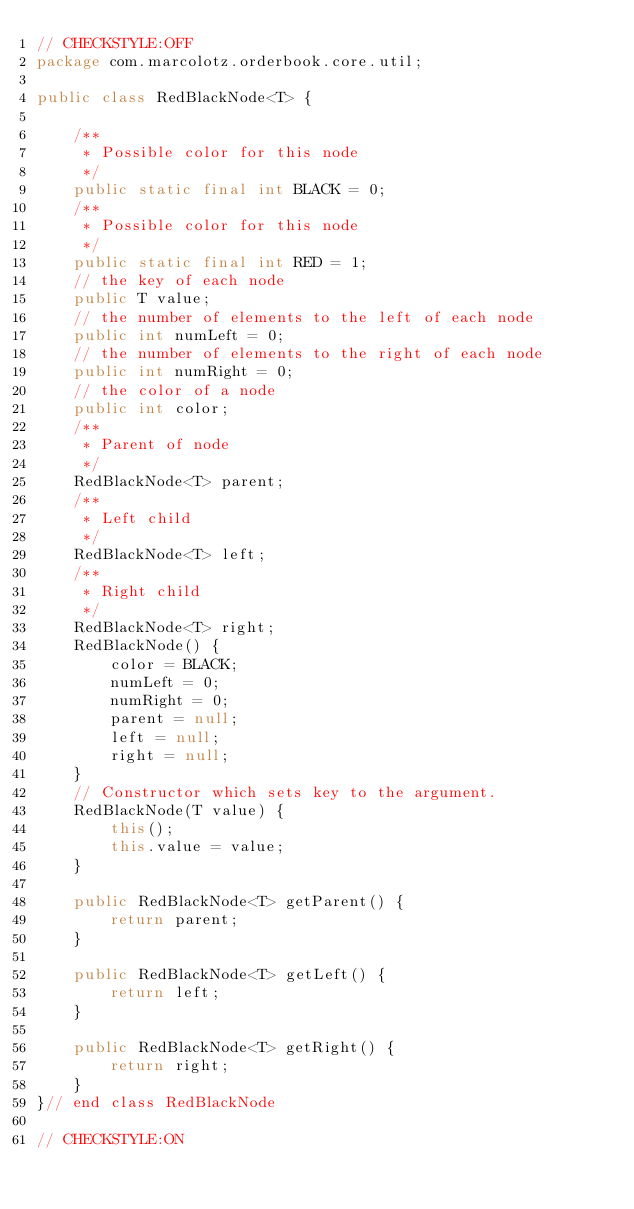Convert code to text. <code><loc_0><loc_0><loc_500><loc_500><_Java_>// CHECKSTYLE:OFF
package com.marcolotz.orderbook.core.util;

public class RedBlackNode<T> {

    /**
     * Possible color for this node
     */
    public static final int BLACK = 0;
    /**
     * Possible color for this node
     */
    public static final int RED = 1;
    // the key of each node
    public T value;
    // the number of elements to the left of each node
    public int numLeft = 0;
    // the number of elements to the right of each node
    public int numRight = 0;
    // the color of a node
    public int color;
    /**
     * Parent of node
     */
    RedBlackNode<T> parent;
    /**
     * Left child
     */
    RedBlackNode<T> left;
    /**
     * Right child
     */
    RedBlackNode<T> right;
    RedBlackNode() {
        color = BLACK;
        numLeft = 0;
        numRight = 0;
        parent = null;
        left = null;
        right = null;
    }
    // Constructor which sets key to the argument.
    RedBlackNode(T value) {
        this();
        this.value = value;
    }

    public RedBlackNode<T> getParent() {
        return parent;
    }

    public RedBlackNode<T> getLeft() {
        return left;
    }

    public RedBlackNode<T> getRight() {
        return right;
    }
}// end class RedBlackNode

// CHECKSTYLE:ON</code> 